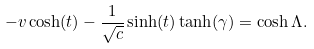Convert formula to latex. <formula><loc_0><loc_0><loc_500><loc_500>- v \cosh ( t ) - \frac { 1 } { \sqrt { c } } \sinh ( t ) \tanh ( \gamma ) = \cosh \Lambda .</formula> 